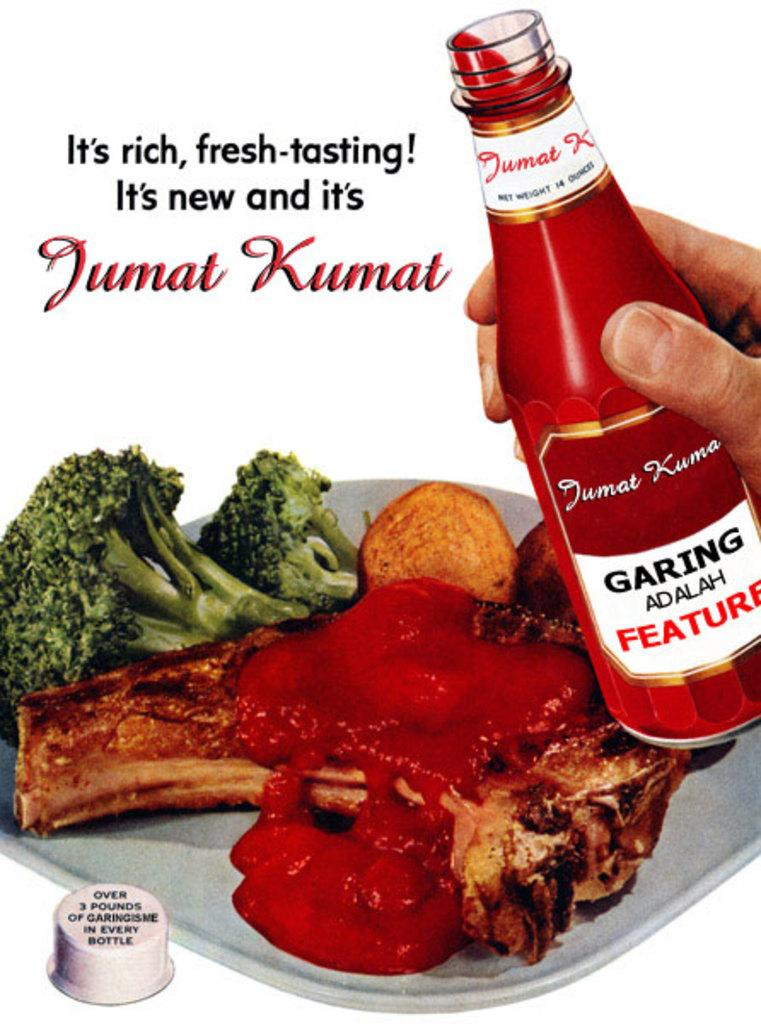<image>
Create a compact narrative representing the image presented. An advertisement for Jumat Kumat sauce includes a plate of food with the sauce poured over meat. 